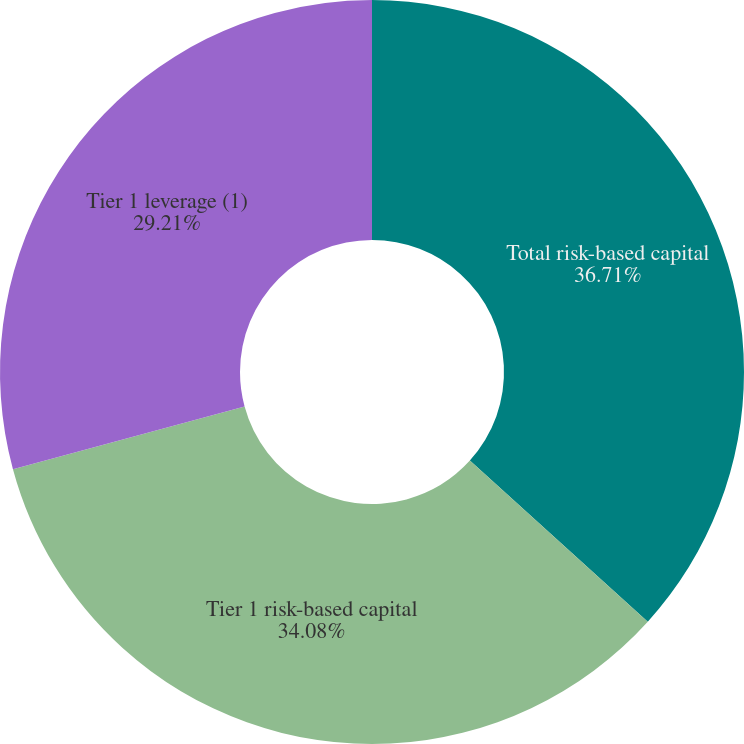Convert chart. <chart><loc_0><loc_0><loc_500><loc_500><pie_chart><fcel>Total risk-based capital<fcel>Tier 1 risk-based capital<fcel>Tier 1 leverage (1)<nl><fcel>36.71%<fcel>34.08%<fcel>29.21%<nl></chart> 